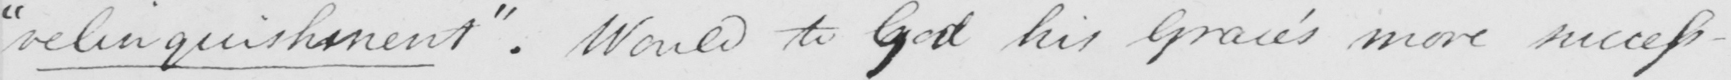Please transcribe the handwritten text in this image. " relinquishment "  . Would to God his Grace ' s more success- 